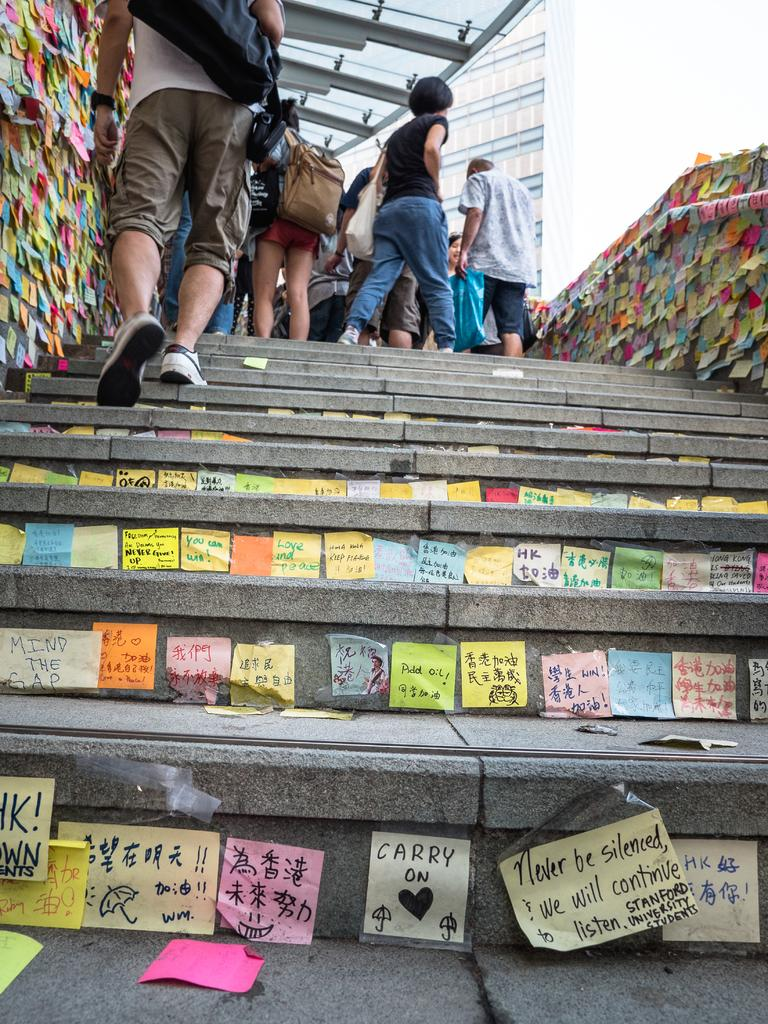<image>
Summarize the visual content of the image. Steps with many stickers including one that says CARRY ON. 